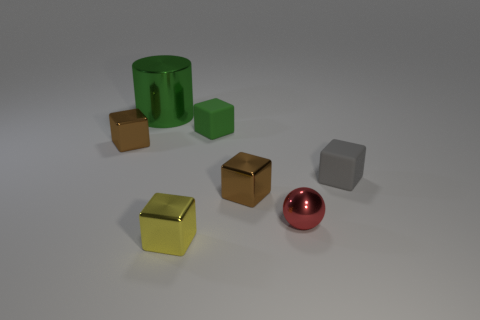Subtract all green blocks. How many blocks are left? 4 Subtract all green cubes. How many cubes are left? 4 Subtract all cyan blocks. Subtract all blue spheres. How many blocks are left? 5 Add 3 yellow blocks. How many objects exist? 10 Subtract all cubes. How many objects are left? 2 Subtract 0 green balls. How many objects are left? 7 Subtract all brown cubes. Subtract all rubber objects. How many objects are left? 3 Add 1 tiny shiny objects. How many tiny shiny objects are left? 5 Add 7 small green metallic cylinders. How many small green metallic cylinders exist? 7 